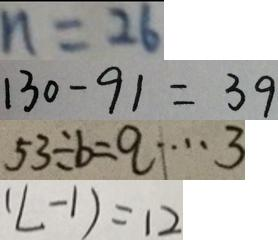<formula> <loc_0><loc_0><loc_500><loc_500>n = 2 6 
 1 3 0 - 9 1 = 3 9 
 5 3 \div b = q \cdots 3 
 ( L - 1 ) = 1 2</formula> 